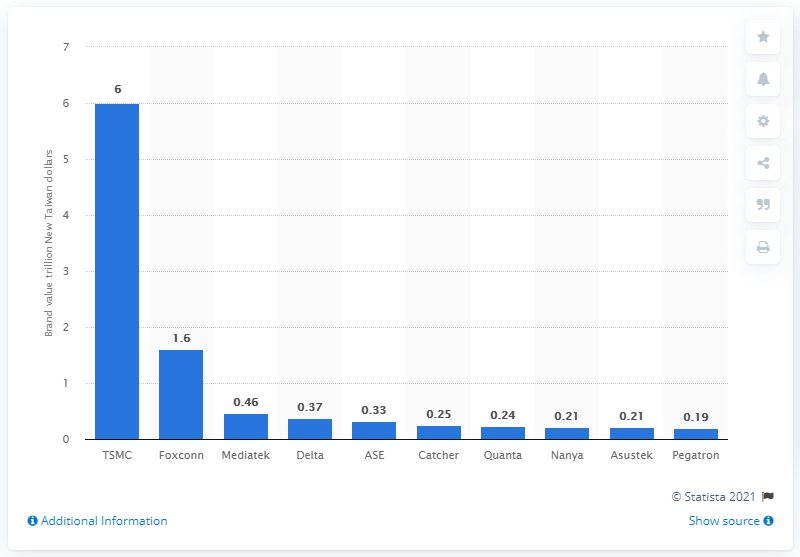Indicate a few pertinent items in this graphic. The lowest value in the blue bar is 0.19. The value of the highest dark blue bar is 6. According to the information available as of December 2017, the most valuable technology company in Taiwan was TSMC. 